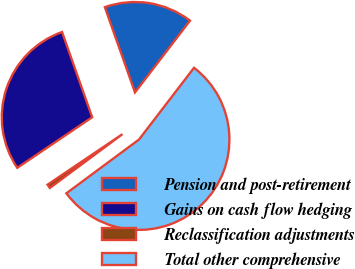<chart> <loc_0><loc_0><loc_500><loc_500><pie_chart><fcel>Pension and post-retirement<fcel>Gains on cash flow hedging<fcel>Reclassification adjustments<fcel>Total other comprehensive<nl><fcel>15.82%<fcel>29.04%<fcel>0.7%<fcel>54.44%<nl></chart> 